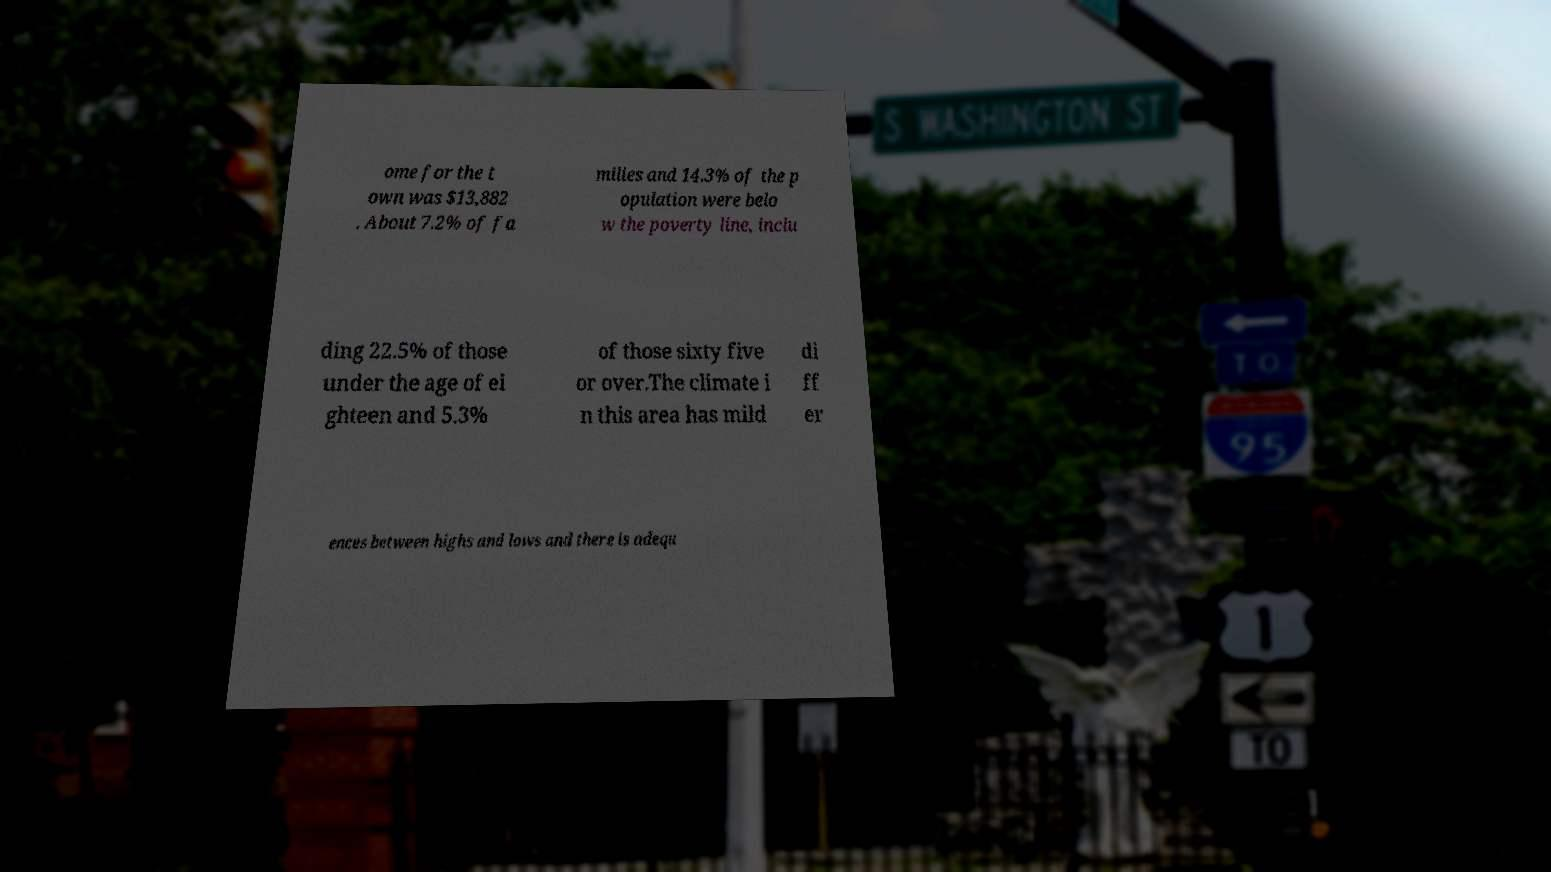Could you extract and type out the text from this image? ome for the t own was $13,882 . About 7.2% of fa milies and 14.3% of the p opulation were belo w the poverty line, inclu ding 22.5% of those under the age of ei ghteen and 5.3% of those sixty five or over.The climate i n this area has mild di ff er ences between highs and lows and there is adequ 